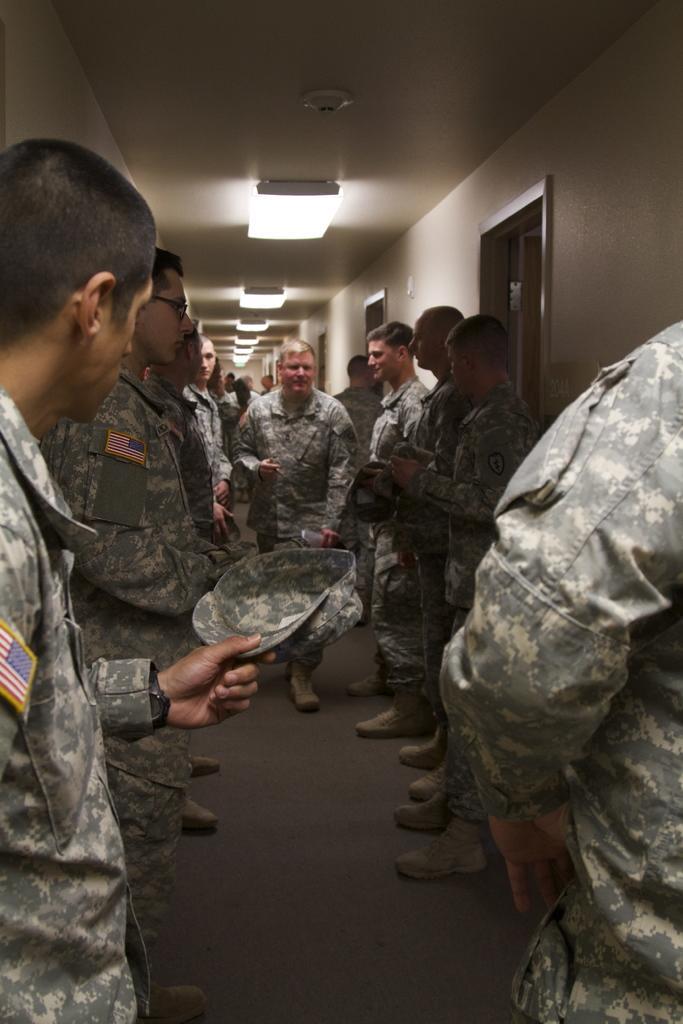How would you summarize this image in a sentence or two? In this picture I can observe some men standing on the floor. All of them are wearing ash color dresses. On the right side I can observe some doors. In the background there are some lights fixed to the ceiling. 